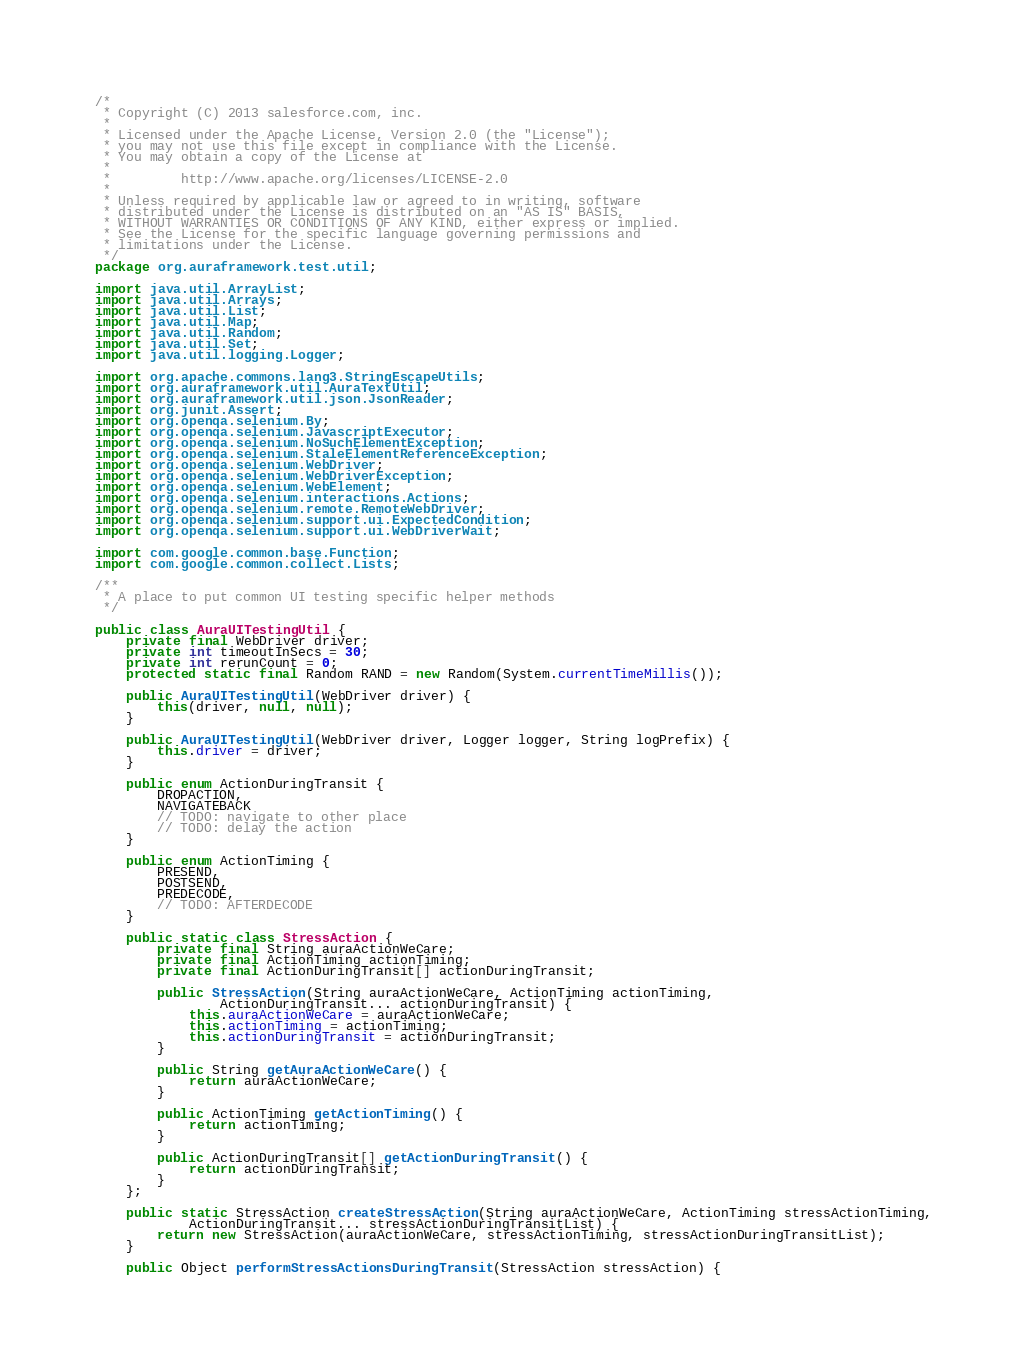Convert code to text. <code><loc_0><loc_0><loc_500><loc_500><_Java_>/*
 * Copyright (C) 2013 salesforce.com, inc.
 *
 * Licensed under the Apache License, Version 2.0 (the "License");
 * you may not use this file except in compliance with the License.
 * You may obtain a copy of the License at
 *
 *         http://www.apache.org/licenses/LICENSE-2.0
 *
 * Unless required by applicable law or agreed to in writing, software
 * distributed under the License is distributed on an "AS IS" BASIS,
 * WITHOUT WARRANTIES OR CONDITIONS OF ANY KIND, either express or implied.
 * See the License for the specific language governing permissions and
 * limitations under the License.
 */
package org.auraframework.test.util;

import java.util.ArrayList;
import java.util.Arrays;
import java.util.List;
import java.util.Map;
import java.util.Random;
import java.util.Set;
import java.util.logging.Logger;

import org.apache.commons.lang3.StringEscapeUtils;
import org.auraframework.util.AuraTextUtil;
import org.auraframework.util.json.JsonReader;
import org.junit.Assert;
import org.openqa.selenium.By;
import org.openqa.selenium.JavascriptExecutor;
import org.openqa.selenium.NoSuchElementException;
import org.openqa.selenium.StaleElementReferenceException;
import org.openqa.selenium.WebDriver;
import org.openqa.selenium.WebDriverException;
import org.openqa.selenium.WebElement;
import org.openqa.selenium.interactions.Actions;
import org.openqa.selenium.remote.RemoteWebDriver;
import org.openqa.selenium.support.ui.ExpectedCondition;
import org.openqa.selenium.support.ui.WebDriverWait;

import com.google.common.base.Function;
import com.google.common.collect.Lists;

/**
 * A place to put common UI testing specific helper methods
 */

public class AuraUITestingUtil {
    private final WebDriver driver;
    private int timeoutInSecs = 30;
    private int rerunCount = 0;
    protected static final Random RAND = new Random(System.currentTimeMillis());

    public AuraUITestingUtil(WebDriver driver) {
        this(driver, null, null);
    }

    public AuraUITestingUtil(WebDriver driver, Logger logger, String logPrefix) {
        this.driver = driver;
    }

    public enum ActionDuringTransit {
        DROPACTION,
        NAVIGATEBACK
        // TODO: navigate to other place
        // TODO: delay the action
    }

    public enum ActionTiming {
        PRESEND,
        POSTSEND,
        PREDECODE,
        // TODO: AFTERDECODE
    }

    public static class StressAction {
        private final String auraActionWeCare;
        private final ActionTiming actionTiming;
        private final ActionDuringTransit[] actionDuringTransit;

        public StressAction(String auraActionWeCare, ActionTiming actionTiming,
                ActionDuringTransit... actionDuringTransit) {
            this.auraActionWeCare = auraActionWeCare;
            this.actionTiming = actionTiming;
            this.actionDuringTransit = actionDuringTransit;
        }

        public String getAuraActionWeCare() {
            return auraActionWeCare;
        }

        public ActionTiming getActionTiming() {
            return actionTiming;
        }

        public ActionDuringTransit[] getActionDuringTransit() {
            return actionDuringTransit;
        }
    };

    public static StressAction createStressAction(String auraActionWeCare, ActionTiming stressActionTiming,
            ActionDuringTransit... stressActionDuringTransitList) {
        return new StressAction(auraActionWeCare, stressActionTiming, stressActionDuringTransitList);
    }

    public Object performStressActionsDuringTransit(StressAction stressAction) {</code> 